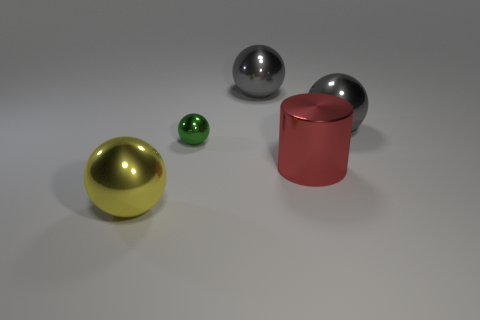What number of balls are right of the small metal object? There are two balls positioned to the right of the small metal object. Closest to the object is a lustrous, medium-sized silver ball, and farther right is the large gold-colored ball. 